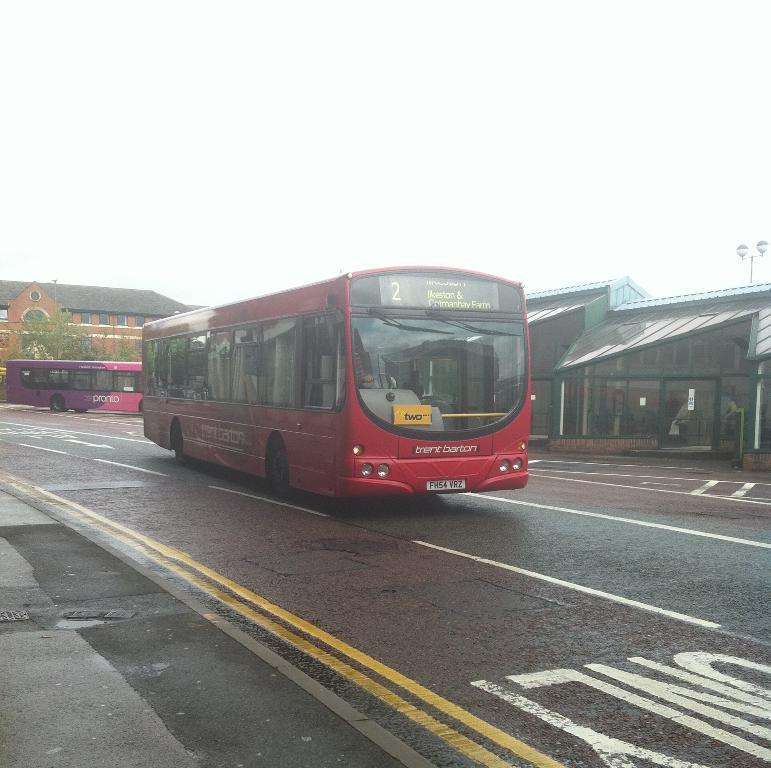Describe this image in one or two sentences. On the road there are two buses moving beside a bus bay and in the background there is a building and the climate is breezy. 